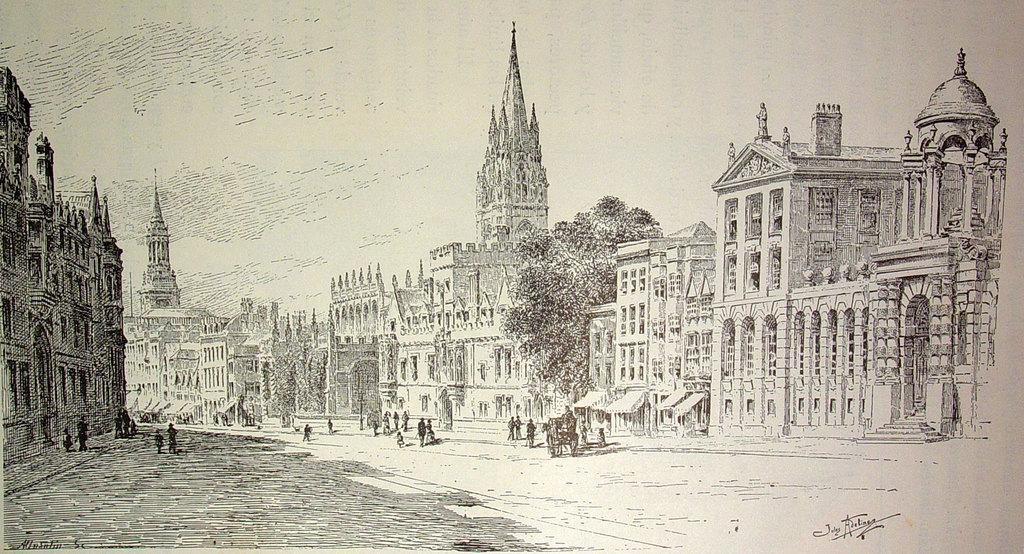Describe this image in one or two sentences. This is an edited image in which there are buildings, trees and there are persons. 